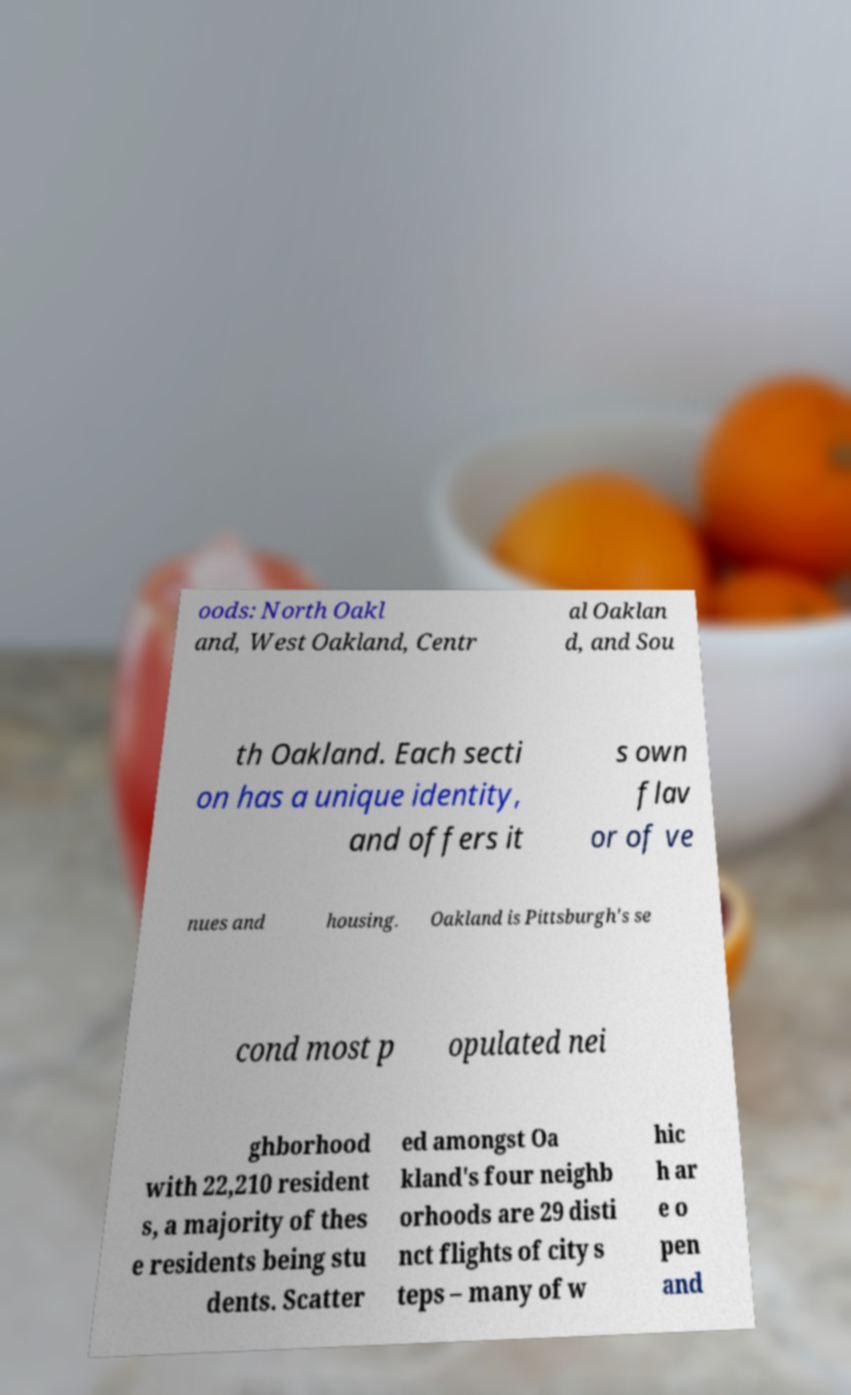Could you assist in decoding the text presented in this image and type it out clearly? oods: North Oakl and, West Oakland, Centr al Oaklan d, and Sou th Oakland. Each secti on has a unique identity, and offers it s own flav or of ve nues and housing. Oakland is Pittsburgh's se cond most p opulated nei ghborhood with 22,210 resident s, a majority of thes e residents being stu dents. Scatter ed amongst Oa kland's four neighb orhoods are 29 disti nct flights of city s teps – many of w hic h ar e o pen and 